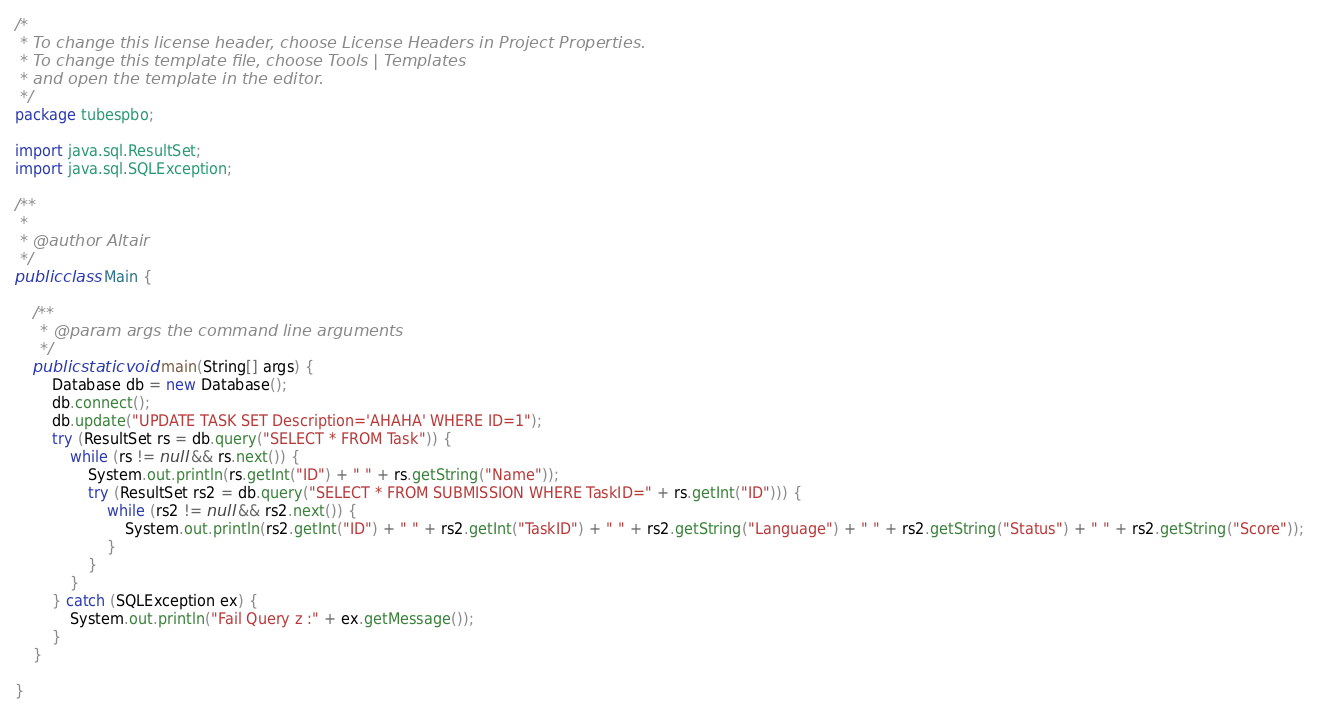<code> <loc_0><loc_0><loc_500><loc_500><_Java_>/*
 * To change this license header, choose License Headers in Project Properties.
 * To change this template file, choose Tools | Templates
 * and open the template in the editor.
 */
package tubespbo;

import java.sql.ResultSet;
import java.sql.SQLException;

/**
 *
 * @author Altair
 */
public class Main {

    /**
     * @param args the command line arguments
     */
    public static void main(String[] args) {
        Database db = new Database();
        db.connect();
        db.update("UPDATE TASK SET Description='AHAHA' WHERE ID=1");
        try (ResultSet rs = db.query("SELECT * FROM Task")) {
            while (rs != null && rs.next()) {
                System.out.println(rs.getInt("ID") + " " + rs.getString("Name"));
                try (ResultSet rs2 = db.query("SELECT * FROM SUBMISSION WHERE TaskID=" + rs.getInt("ID"))) {
                    while (rs2 != null && rs2.next()) {
                        System.out.println(rs2.getInt("ID") + " " + rs2.getInt("TaskID") + " " + rs2.getString("Language") + " " + rs2.getString("Status") + " " + rs2.getString("Score"));
                    }
                }
            }
        } catch (SQLException ex) {
            System.out.println("Fail Query z :" + ex.getMessage());
        }
    }
    
}
</code> 